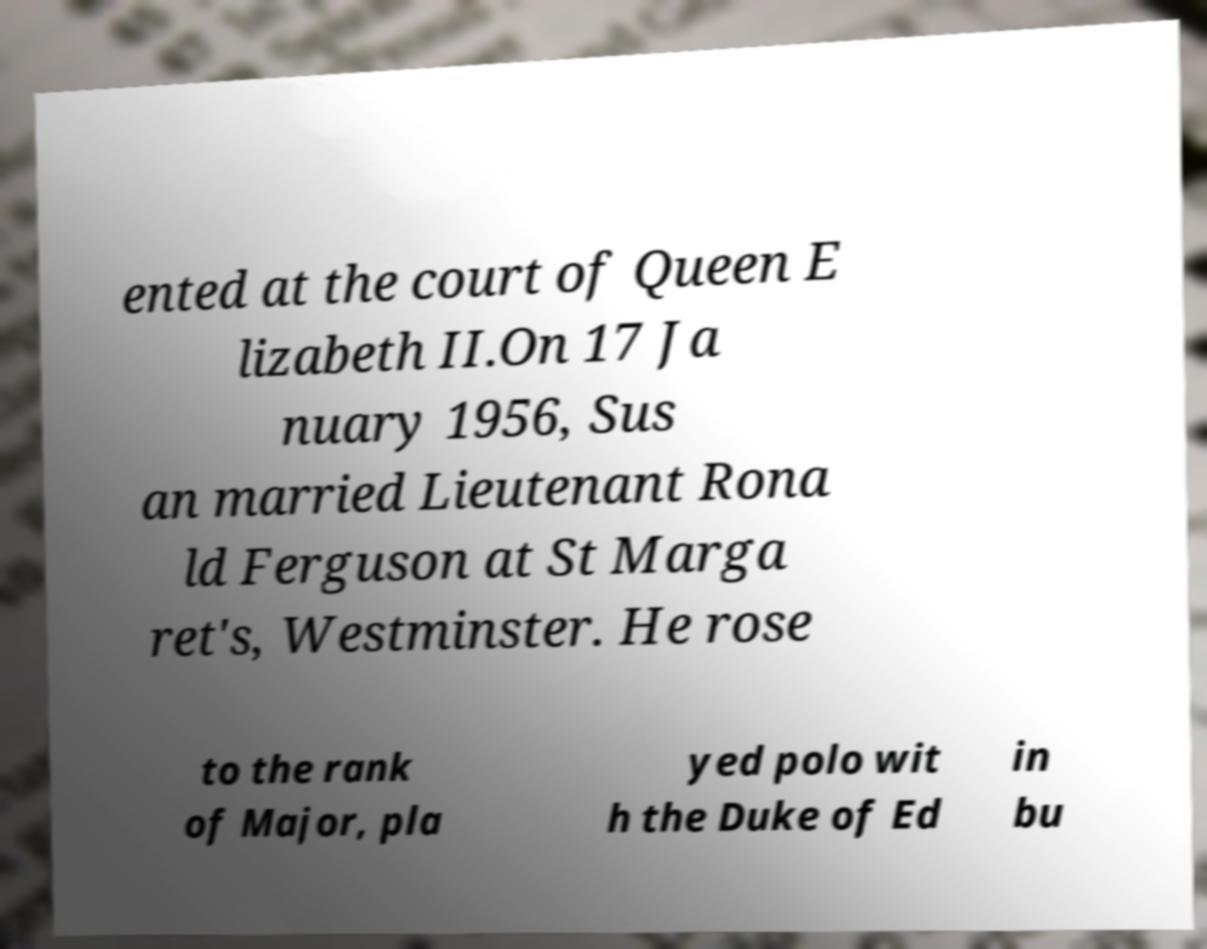Can you accurately transcribe the text from the provided image for me? ented at the court of Queen E lizabeth II.On 17 Ja nuary 1956, Sus an married Lieutenant Rona ld Ferguson at St Marga ret's, Westminster. He rose to the rank of Major, pla yed polo wit h the Duke of Ed in bu 